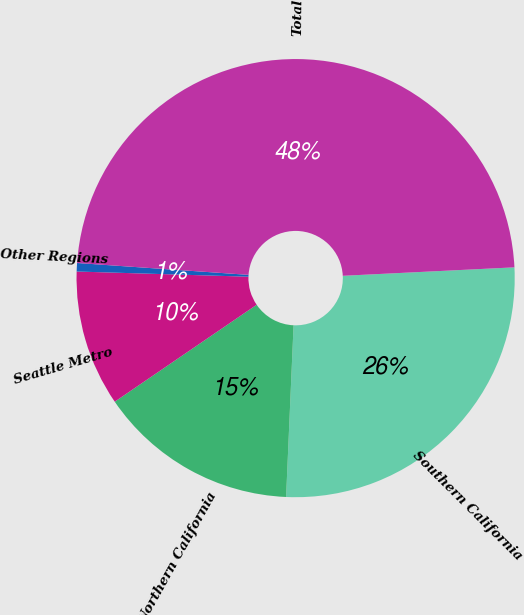Convert chart to OTSL. <chart><loc_0><loc_0><loc_500><loc_500><pie_chart><fcel>Southern California<fcel>Northern California<fcel>Seattle Metro<fcel>Other Regions<fcel>Total<nl><fcel>26.48%<fcel>14.77%<fcel>10.02%<fcel>0.62%<fcel>48.12%<nl></chart> 